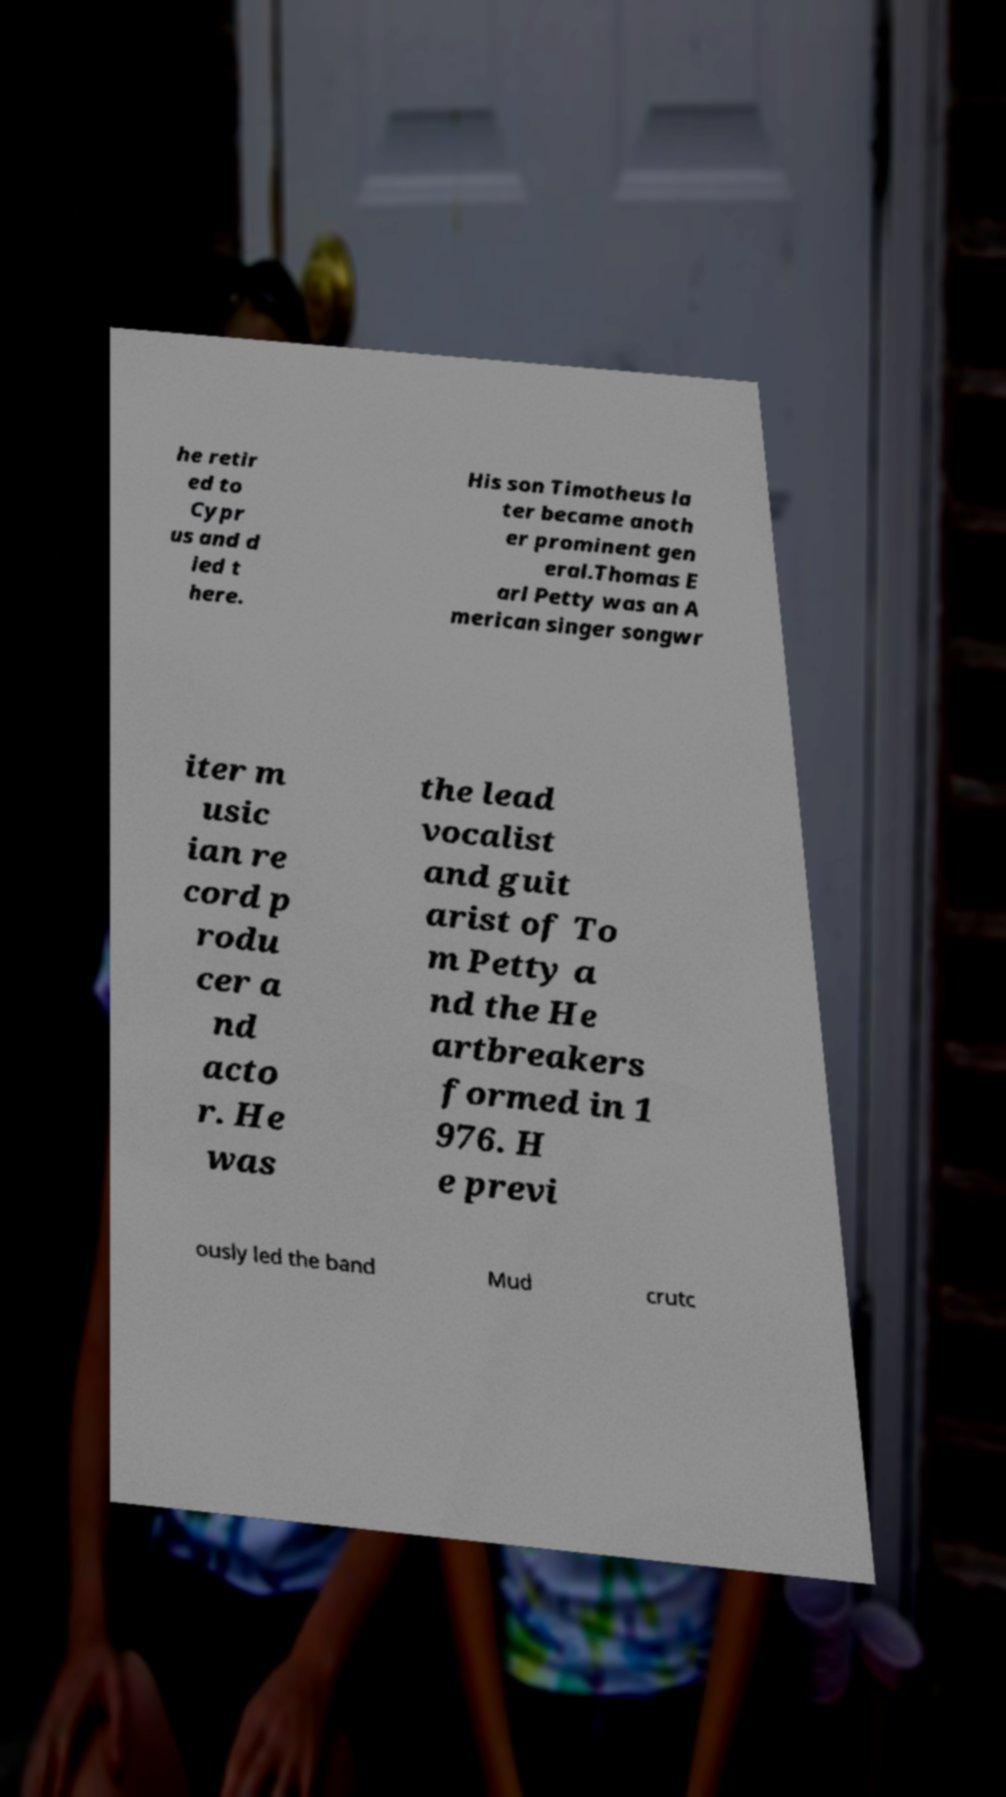For documentation purposes, I need the text within this image transcribed. Could you provide that? he retir ed to Cypr us and d ied t here. His son Timotheus la ter became anoth er prominent gen eral.Thomas E arl Petty was an A merican singer songwr iter m usic ian re cord p rodu cer a nd acto r. He was the lead vocalist and guit arist of To m Petty a nd the He artbreakers formed in 1 976. H e previ ously led the band Mud crutc 